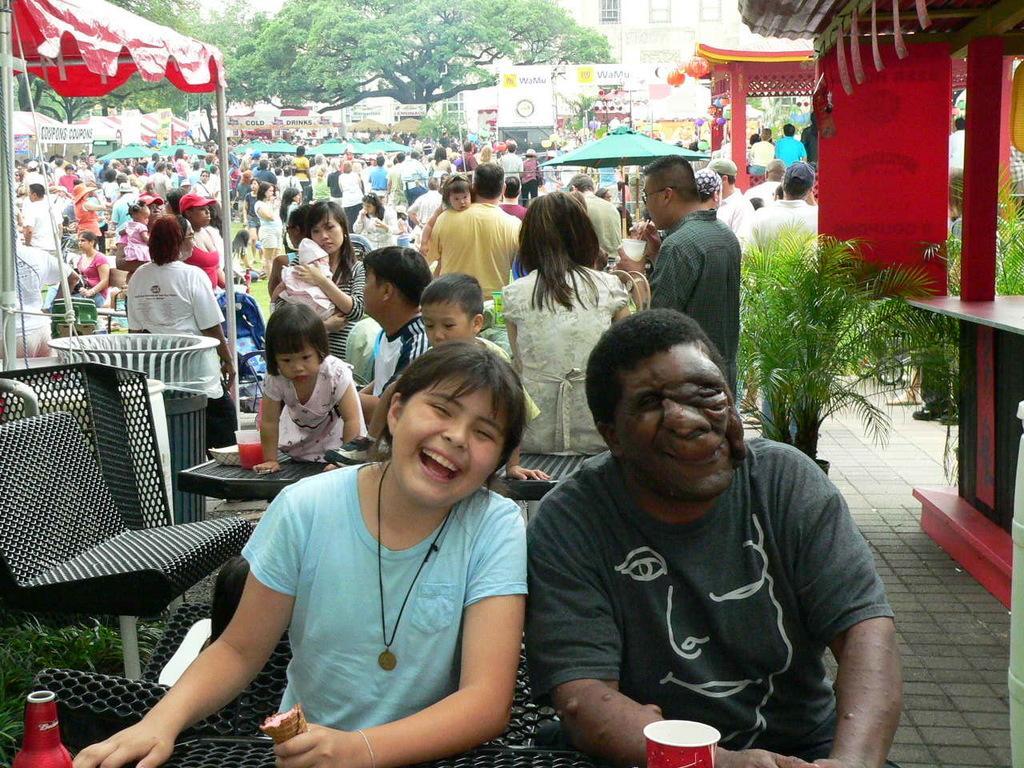In one or two sentences, can you explain what this image depicts? In this image there are many people. Few are standing and few are sitting on the chairs in front of the table. Image also consists of many buildings, hoardings and trees. There are also roofs for shelter. Plants are also visible. There is a cup, a red color bottle and also trash bin in this image. 